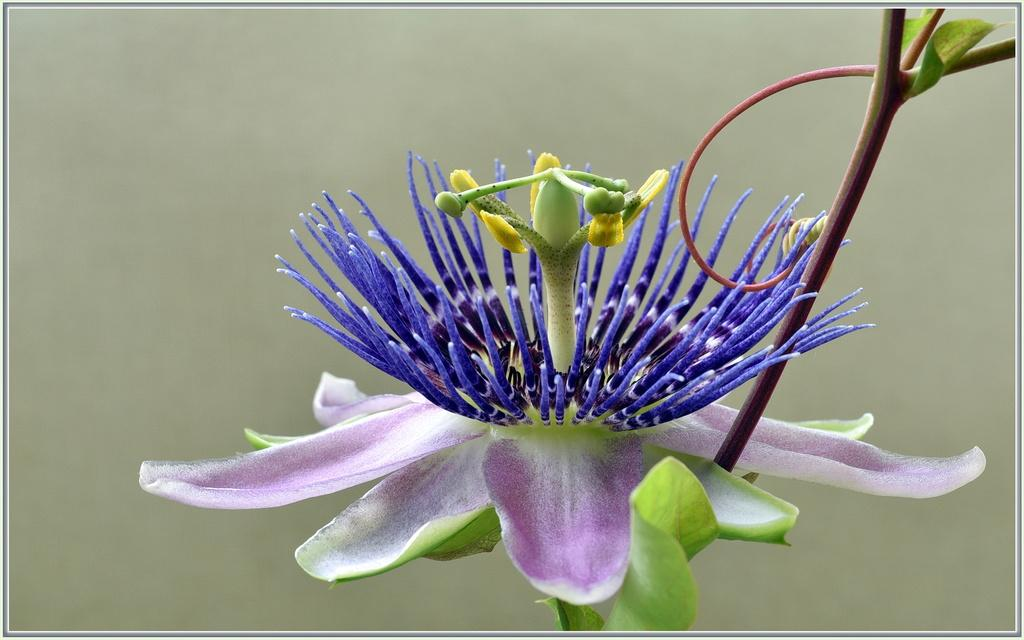What is the main subject of the image? There is a flower in the center of the image. Can you describe the flower in the image? Unfortunately, the facts provided do not give any details about the flower's appearance. Is there anything else in the image besides the flower? The facts provided do not mention any other objects or subjects in the image. What type of voyage is the wren embarking on in the image? There is no wren present in the image, so it is not possible to answer that question. 